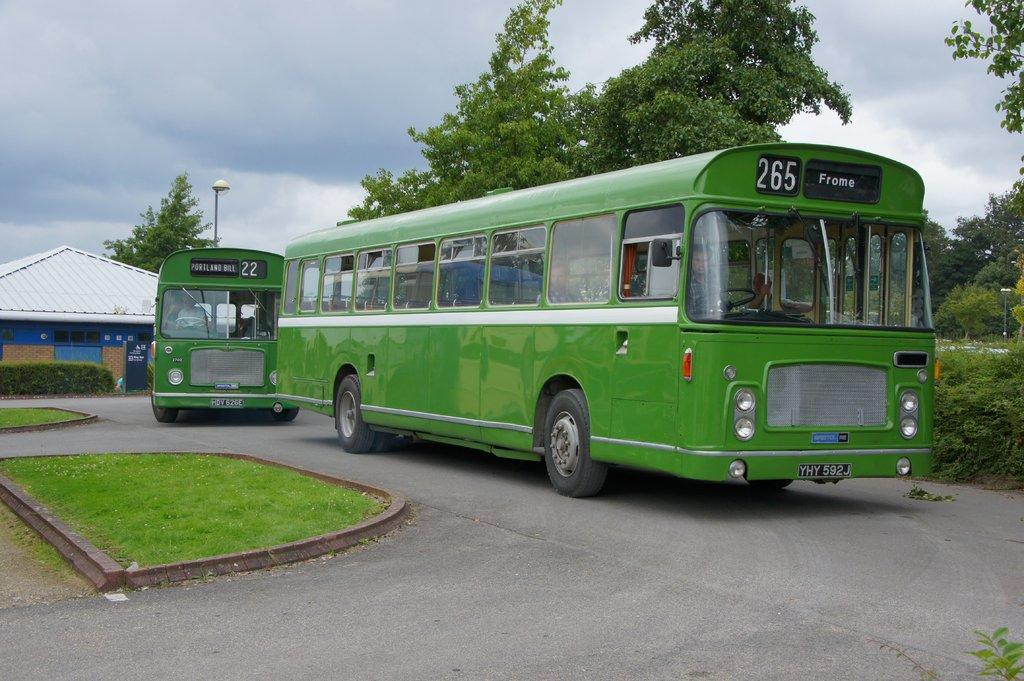What type of vehicles can be seen on the road in the image? There are green buses on the road in the image. What type of vegetation is visible in the image? There is grass and plants visible in the image. Can you describe the lighting in the image? There is a light on a pole in the image. What is visible in the background of the image? There is a house, trees, a light on a pole, and the sky visible in the background of the image. What can be seen in the sky in the image? Clouds are present in the sky in the image. What type of zinc is present in the image? There is no zinc present in the image. What type of linen can be seen draped over the buses in the image? There is no linen present in the image. 